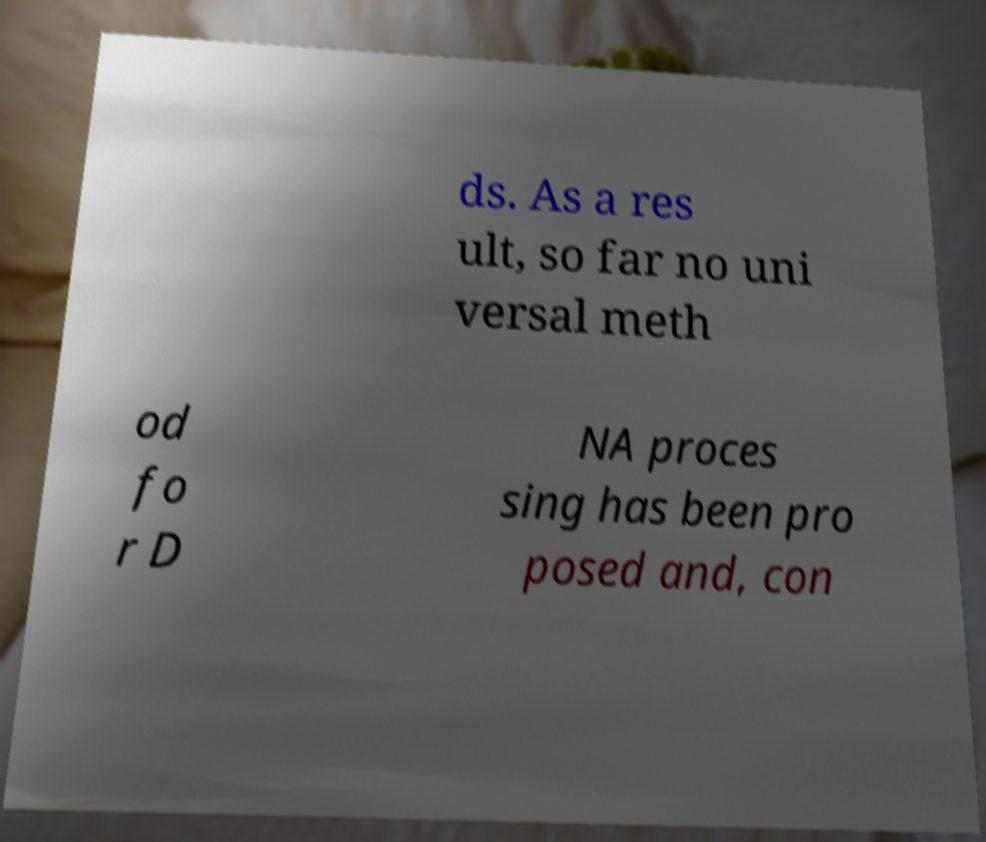Can you accurately transcribe the text from the provided image for me? ds. As a res ult, so far no uni versal meth od fo r D NA proces sing has been pro posed and, con 